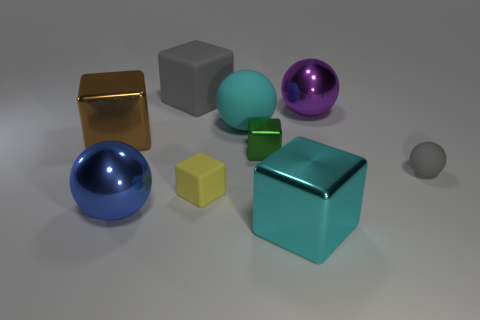Are there any big cyan cylinders?
Your answer should be compact. No. Is the color of the small sphere the same as the small metal cube?
Provide a short and direct response. No. What number of large things are either matte blocks or cyan shiny balls?
Your response must be concise. 1. Is there any other thing that has the same color as the tiny rubber ball?
Offer a terse response. Yes. What shape is the yellow thing that is made of the same material as the gray sphere?
Your answer should be compact. Cube. What size is the rubber sphere that is on the right side of the small green shiny object?
Your answer should be compact. Small. What shape is the large cyan metal thing?
Keep it short and to the point. Cube. There is a green shiny cube that is behind the small yellow matte thing; is it the same size as the cyan thing that is behind the green block?
Provide a succinct answer. No. How big is the shiny ball to the left of the matte cube that is in front of the gray rubber thing that is right of the gray rubber block?
Make the answer very short. Large. What is the shape of the cyan thing that is behind the large sphere that is on the left side of the gray thing behind the big cyan rubber object?
Provide a succinct answer. Sphere. 